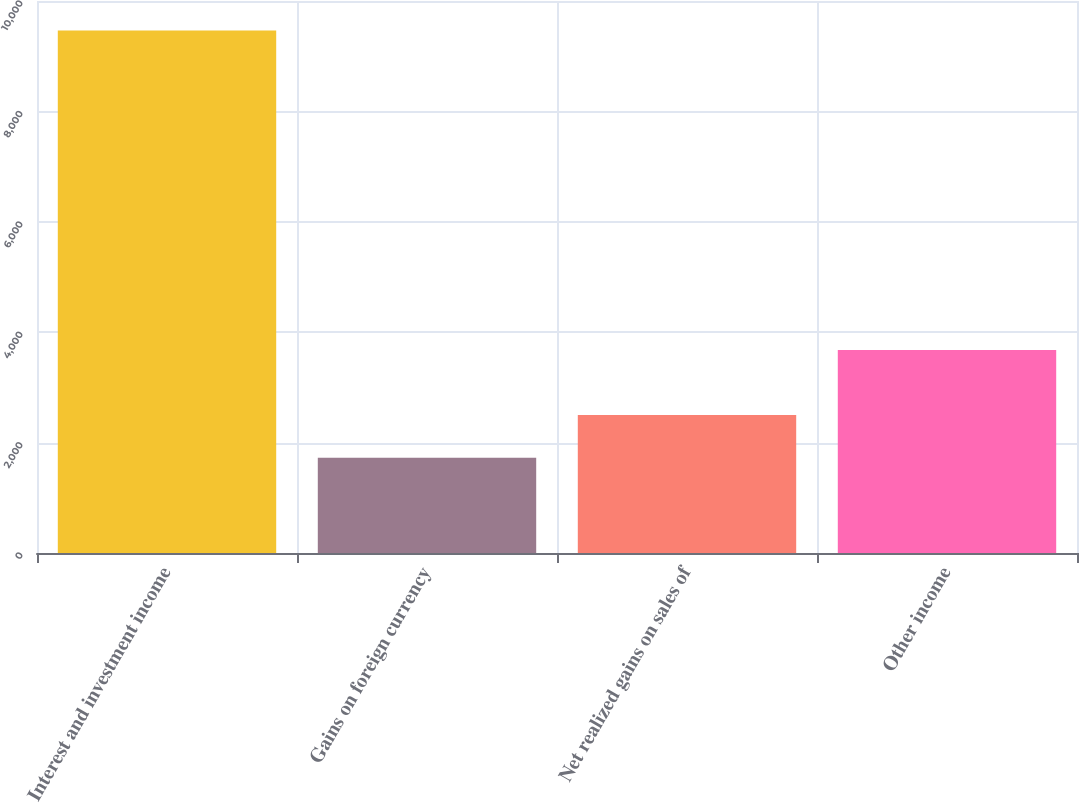Convert chart to OTSL. <chart><loc_0><loc_0><loc_500><loc_500><bar_chart><fcel>Interest and investment income<fcel>Gains on foreign currency<fcel>Net realized gains on sales of<fcel>Other income<nl><fcel>9466<fcel>1727<fcel>2500.9<fcel>3678<nl></chart> 